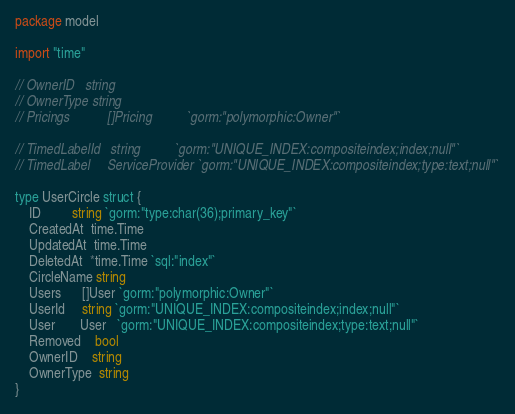<code> <loc_0><loc_0><loc_500><loc_500><_Go_>package model

import "time"

// OwnerID   string
// OwnerType string
// Pricings           []Pricing          `gorm:"polymorphic:Owner"`

// TimedLabelId   string          `gorm:"UNIQUE_INDEX:compositeindex;index;null"`
// TimedLabel     ServiceProvider `gorm:"UNIQUE_INDEX:compositeindex;type:text;null"`

type UserCircle struct {
	ID         string `gorm:"type:char(36);primary_key"`
	CreatedAt  time.Time
	UpdatedAt  time.Time
	DeletedAt  *time.Time `sql:"index"`
	CircleName string
	Users      []User `gorm:"polymorphic:Owner"`
	UserId     string `gorm:"UNIQUE_INDEX:compositeindex;index;null"`
	User       User   `gorm:"UNIQUE_INDEX:compositeindex;type:text;null"`
	Removed    bool
	OwnerID    string
	OwnerType  string
}
</code> 